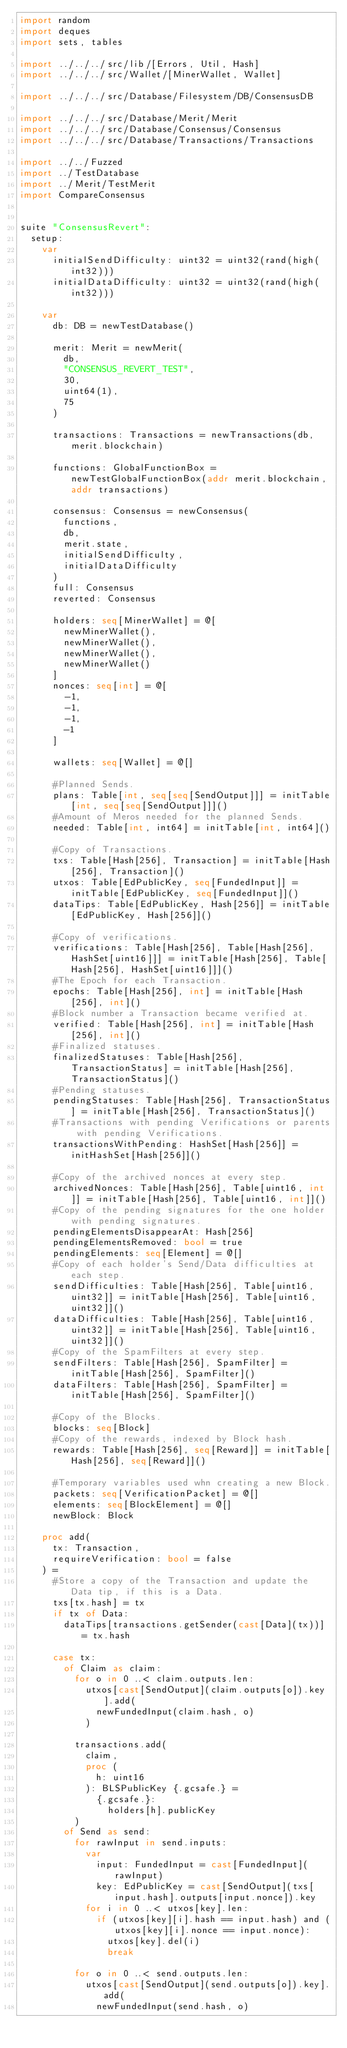<code> <loc_0><loc_0><loc_500><loc_500><_Nim_>import random
import deques
import sets, tables

import ../../../src/lib/[Errors, Util, Hash]
import ../../../src/Wallet/[MinerWallet, Wallet]

import ../../../src/Database/Filesystem/DB/ConsensusDB

import ../../../src/Database/Merit/Merit
import ../../../src/Database/Consensus/Consensus
import ../../../src/Database/Transactions/Transactions

import ../../Fuzzed
import ../TestDatabase
import ../Merit/TestMerit
import CompareConsensus


suite "ConsensusRevert":
  setup:
    var
      initialSendDifficulty: uint32 = uint32(rand(high(int32)))
      initialDataDifficulty: uint32 = uint32(rand(high(int32)))

    var
      db: DB = newTestDatabase()

      merit: Merit = newMerit(
        db,
        "CONSENSUS_REVERT_TEST",
        30,
        uint64(1),
        75
      )

      transactions: Transactions = newTransactions(db, merit.blockchain)

      functions: GlobalFunctionBox = newTestGlobalFunctionBox(addr merit.blockchain, addr transactions)

      consensus: Consensus = newConsensus(
        functions,
        db,
        merit.state,
        initialSendDifficulty,
        initialDataDifficulty
      )
      full: Consensus
      reverted: Consensus

      holders: seq[MinerWallet] = @[
        newMinerWallet(),
        newMinerWallet(),
        newMinerWallet(),
        newMinerWallet()
      ]
      nonces: seq[int] = @[
        -1,
        -1,
        -1,
        -1
      ]

      wallets: seq[Wallet] = @[]

      #Planned Sends.
      plans: Table[int, seq[seq[SendOutput]]] = initTable[int, seq[seq[SendOutput]]]()
      #Amount of Meros needed for the planned Sends.
      needed: Table[int, int64] = initTable[int, int64]()

      #Copy of Transactions.
      txs: Table[Hash[256], Transaction] = initTable[Hash[256], Transaction]()
      utxos: Table[EdPublicKey, seq[FundedInput]] = initTable[EdPublicKey, seq[FundedInput]]()
      dataTips: Table[EdPublicKey, Hash[256]] = initTable[EdPublicKey, Hash[256]]()

      #Copy of verifications.
      verifications: Table[Hash[256], Table[Hash[256], HashSet[uint16]]] = initTable[Hash[256], Table[Hash[256], HashSet[uint16]]]()
      #The Epoch for each Transaction.
      epochs: Table[Hash[256], int] = initTable[Hash[256], int]()
      #Block number a Transaction became verified at.
      verified: Table[Hash[256], int] = initTable[Hash[256], int]()
      #Finalized statuses.
      finalizedStatuses: Table[Hash[256], TransactionStatus] = initTable[Hash[256], TransactionStatus]()
      #Pending statuses.
      pendingStatuses: Table[Hash[256], TransactionStatus] = initTable[Hash[256], TransactionStatus]()
      #Transactions with pending Verifications or parents with pending Verifications.
      transactionsWithPending: HashSet[Hash[256]] = initHashSet[Hash[256]]()

      #Copy of the archived nonces at every step.
      archivedNonces: Table[Hash[256], Table[uint16, int]] = initTable[Hash[256], Table[uint16, int]]()
      #Copy of the pending signatures for the one holder with pending signatures.
      pendingElementsDisappearAt: Hash[256]
      pendingElementsRemoved: bool = true
      pendingElements: seq[Element] = @[]
      #Copy of each holder's Send/Data difficulties at each step.
      sendDifficulties: Table[Hash[256], Table[uint16, uint32]] = initTable[Hash[256], Table[uint16, uint32]]()
      dataDifficulties: Table[Hash[256], Table[uint16, uint32]] = initTable[Hash[256], Table[uint16, uint32]]()
      #Copy of the SpamFilters at every step.
      sendFilters: Table[Hash[256], SpamFilter] = initTable[Hash[256], SpamFilter]()
      dataFilters: Table[Hash[256], SpamFilter] = initTable[Hash[256], SpamFilter]()

      #Copy of the Blocks.
      blocks: seq[Block]
      #Copy of the rewards, indexed by Block hash.
      rewards: Table[Hash[256], seq[Reward]] = initTable[Hash[256], seq[Reward]]()

      #Temporary variables used whn creating a new Block.
      packets: seq[VerificationPacket] = @[]
      elements: seq[BlockElement] = @[]
      newBlock: Block

    proc add(
      tx: Transaction,
      requireVerification: bool = false
    ) =
      #Store a copy of the Transaction and update the Data tip, if this is a Data.
      txs[tx.hash] = tx
      if tx of Data:
        dataTips[transactions.getSender(cast[Data](tx))] = tx.hash

      case tx:
        of Claim as claim:
          for o in 0 ..< claim.outputs.len:
            utxos[cast[SendOutput](claim.outputs[o]).key].add(
              newFundedInput(claim.hash, o)
            )

          transactions.add(
            claim,
            proc (
              h: uint16
            ): BLSPublicKey {.gcsafe.} =
              {.gcsafe.}:
                holders[h].publicKey
          )
        of Send as send:
          for rawInput in send.inputs:
            var
              input: FundedInput = cast[FundedInput](rawInput)
              key: EdPublicKey = cast[SendOutput](txs[input.hash].outputs[input.nonce]).key
            for i in 0 ..< utxos[key].len:
              if (utxos[key][i].hash == input.hash) and (utxos[key][i].nonce == input.nonce):
                utxos[key].del(i)
                break

          for o in 0 ..< send.outputs.len:
            utxos[cast[SendOutput](send.outputs[o]).key].add(
              newFundedInput(send.hash, o)</code> 